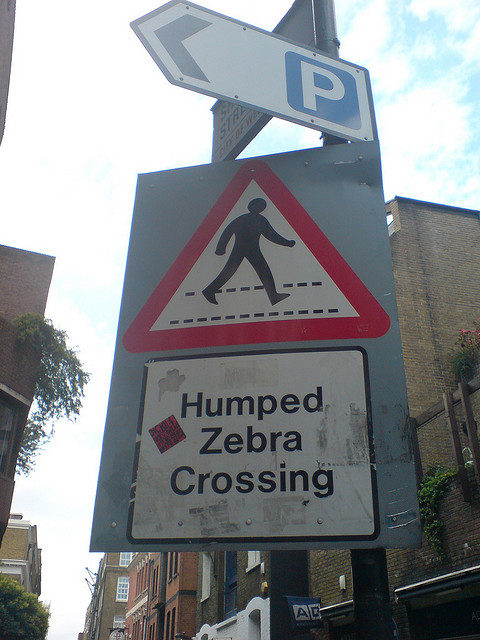Identify the text contained in this image. Humped Zebra Crossing P STR AC 